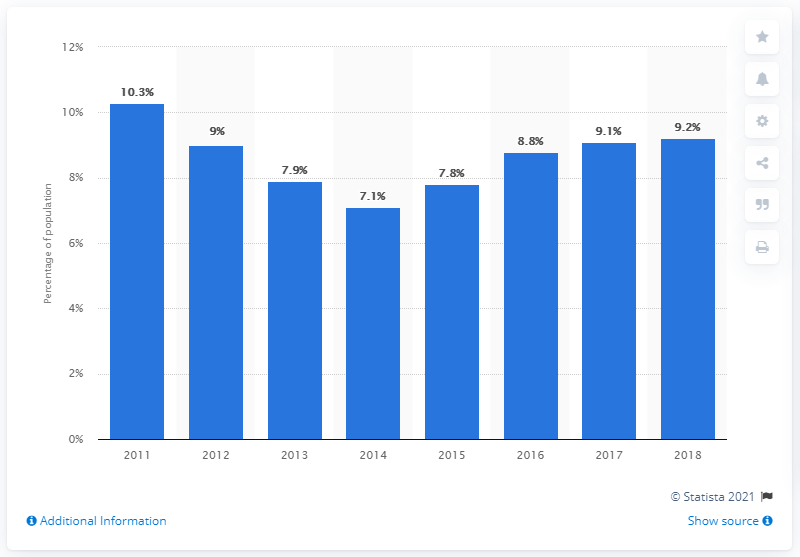Outline some significant characteristics in this image. In 2014, the poverty rate was 9.2%. In 2018, the poverty headcount ratio in Brazil was 9.2 percent. 